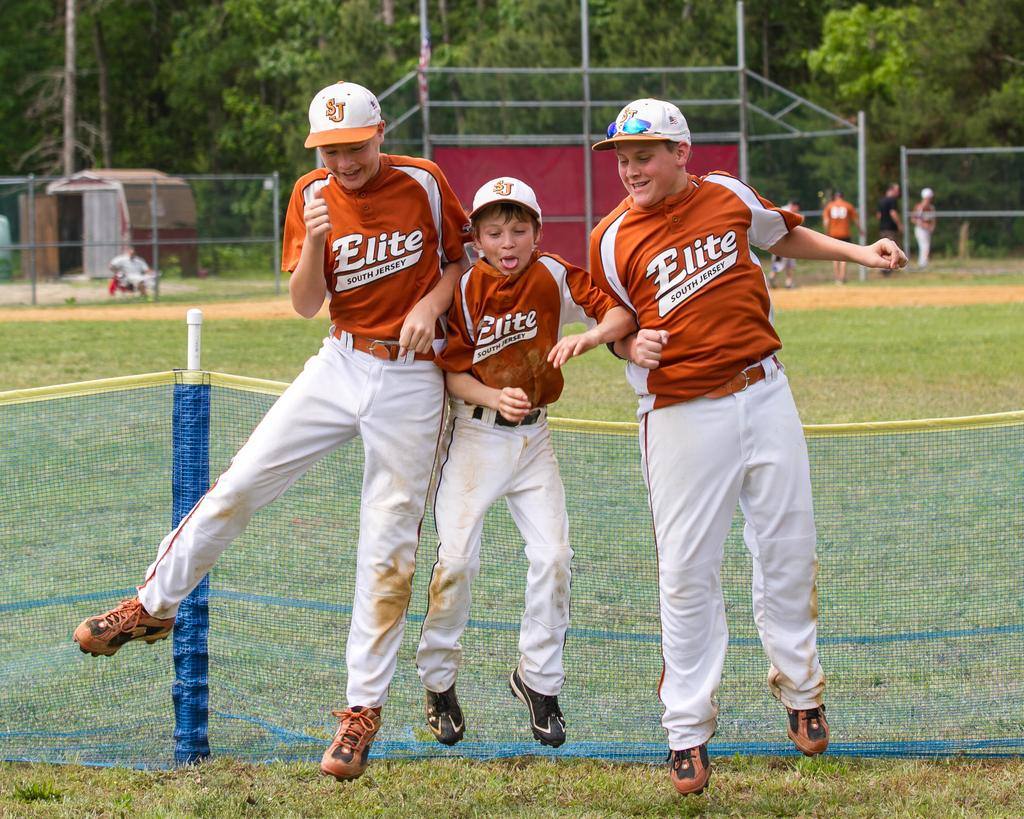<image>
Summarize the visual content of the image. boys wearing uniforms for elite south jersey baseball team jumping in the air against a mesh fence 